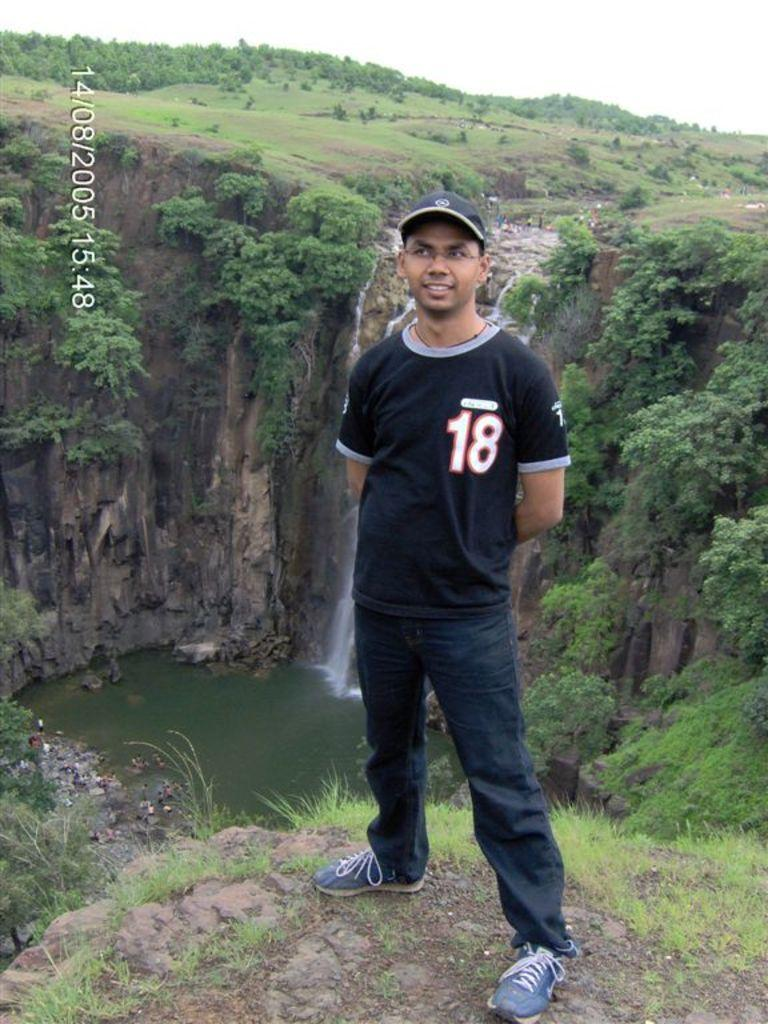What is the main subject in the image? There is a person standing in the image. What type of vegetation can be seen in the image? There are plants, trees, and grass visible in the image. What else can be seen in the image besides the person and vegetation? There is water visible in the image. What is visible in the background of the image? The sky is visible in the background of the image. What type of gold ornament is the person wearing in the image? There is no gold ornament visible on the person in the image. What type of loaf is the person holding in the image? There is no loaf present in the image. 